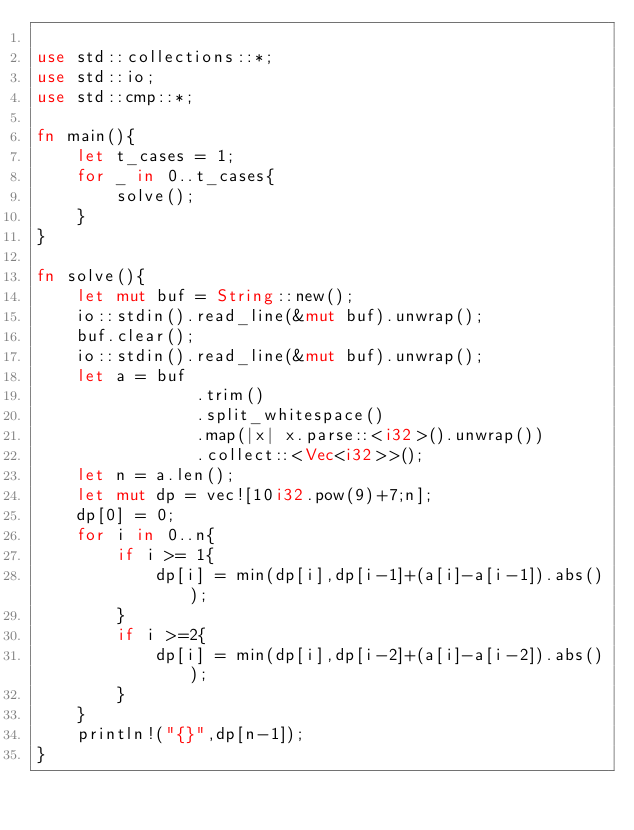<code> <loc_0><loc_0><loc_500><loc_500><_Rust_>
use std::collections::*;
use std::io;
use std::cmp::*;

fn main(){
    let t_cases = 1;
    for _ in 0..t_cases{
        solve();
    }
}

fn solve(){
    let mut buf = String::new();
    io::stdin().read_line(&mut buf).unwrap();
    buf.clear();
    io::stdin().read_line(&mut buf).unwrap();
    let a = buf
                .trim()
                .split_whitespace()
                .map(|x| x.parse::<i32>().unwrap())
                .collect::<Vec<i32>>();
    let n = a.len();
    let mut dp = vec![10i32.pow(9)+7;n];
    dp[0] = 0;
    for i in 0..n{
        if i >= 1{
            dp[i] = min(dp[i],dp[i-1]+(a[i]-a[i-1]).abs());
        }
        if i >=2{
            dp[i] = min(dp[i],dp[i-2]+(a[i]-a[i-2]).abs());
        }
    }
    println!("{}",dp[n-1]);
}</code> 